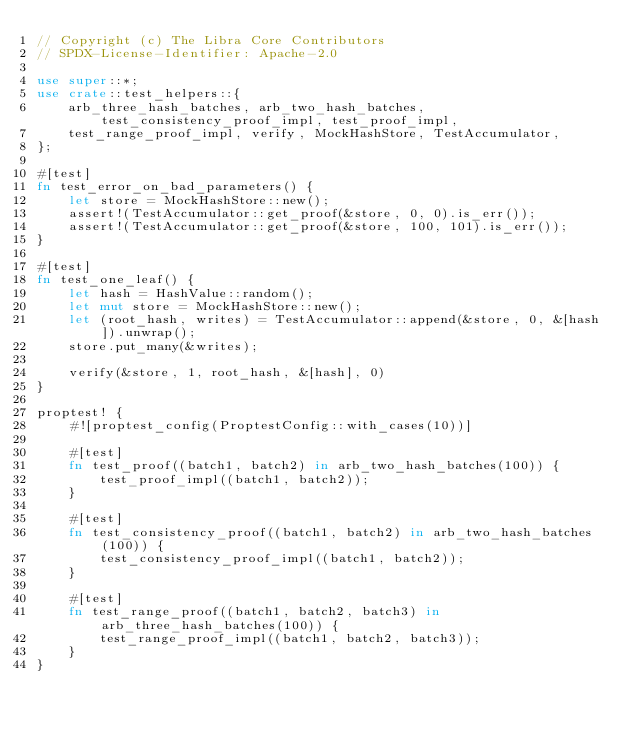<code> <loc_0><loc_0><loc_500><loc_500><_Rust_>// Copyright (c) The Libra Core Contributors
// SPDX-License-Identifier: Apache-2.0

use super::*;
use crate::test_helpers::{
    arb_three_hash_batches, arb_two_hash_batches, test_consistency_proof_impl, test_proof_impl,
    test_range_proof_impl, verify, MockHashStore, TestAccumulator,
};

#[test]
fn test_error_on_bad_parameters() {
    let store = MockHashStore::new();
    assert!(TestAccumulator::get_proof(&store, 0, 0).is_err());
    assert!(TestAccumulator::get_proof(&store, 100, 101).is_err());
}

#[test]
fn test_one_leaf() {
    let hash = HashValue::random();
    let mut store = MockHashStore::new();
    let (root_hash, writes) = TestAccumulator::append(&store, 0, &[hash]).unwrap();
    store.put_many(&writes);

    verify(&store, 1, root_hash, &[hash], 0)
}

proptest! {
    #![proptest_config(ProptestConfig::with_cases(10))]

    #[test]
    fn test_proof((batch1, batch2) in arb_two_hash_batches(100)) {
        test_proof_impl((batch1, batch2));
    }

    #[test]
    fn test_consistency_proof((batch1, batch2) in arb_two_hash_batches(100)) {
        test_consistency_proof_impl((batch1, batch2));
    }

    #[test]
    fn test_range_proof((batch1, batch2, batch3) in arb_three_hash_batches(100)) {
        test_range_proof_impl((batch1, batch2, batch3));
    }
}
</code> 